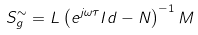Convert formula to latex. <formula><loc_0><loc_0><loc_500><loc_500>S _ { g } ^ { \sim } = L \left ( e ^ { j \omega \tau } I d - N \right ) ^ { - 1 } M</formula> 